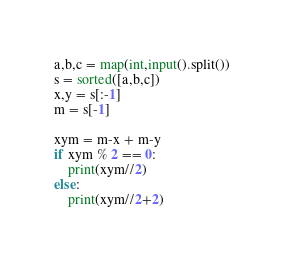Convert code to text. <code><loc_0><loc_0><loc_500><loc_500><_Python_>a,b,c = map(int,input().split())
s = sorted([a,b,c])
x,y = s[:-1]
m = s[-1]

xym = m-x + m-y
if xym % 2 == 0:
    print(xym//2)
else:
    print(xym//2+2)</code> 